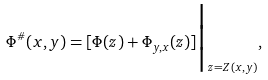Convert formula to latex. <formula><loc_0><loc_0><loc_500><loc_500>\Phi ^ { \# } ( x , y ) = [ \Phi ( z ) + \Phi _ { y , x } ( z ) ] \Big | _ { z = Z ( x , y ) } ,</formula> 